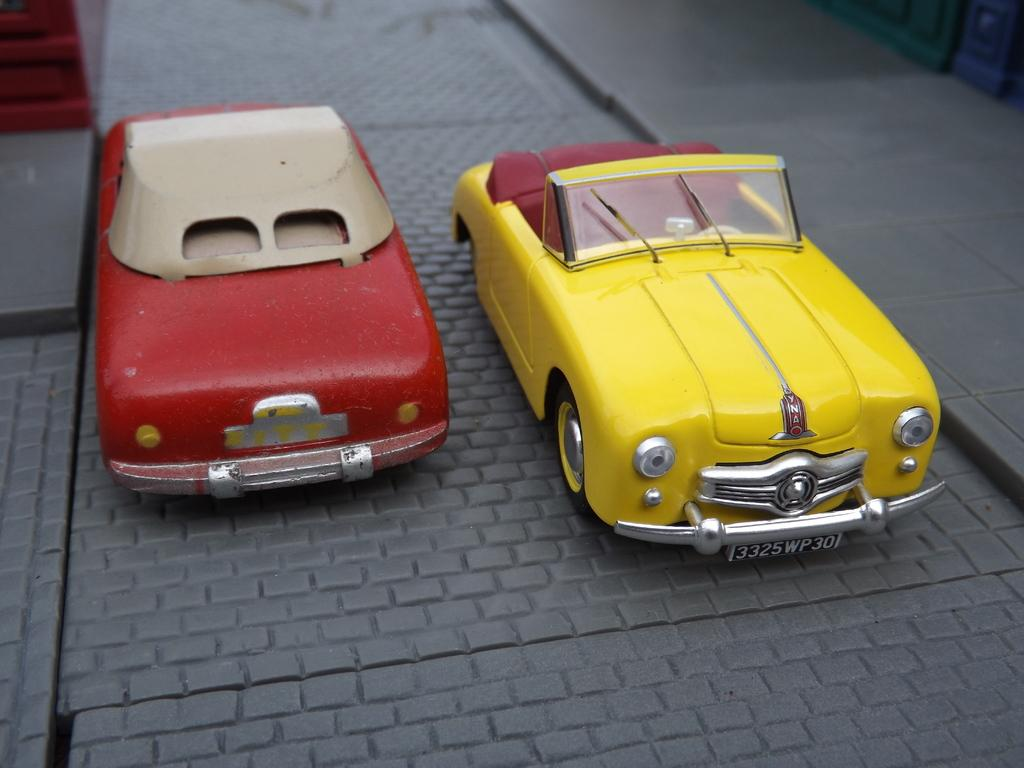What type of toys are present in the image? There are toy cars in the image. Can you describe the toy cars in the image? The toy cars are small, likely made of plastic or metal, and are designed for play. Are there any other toys or objects visible in the image? The provided facts do not mention any other toys or objects in the image, so we cannot definitively answer this question. What type of locket is the dad wearing in the image? There is no dad or locket present in the image; it only features toy cars. 